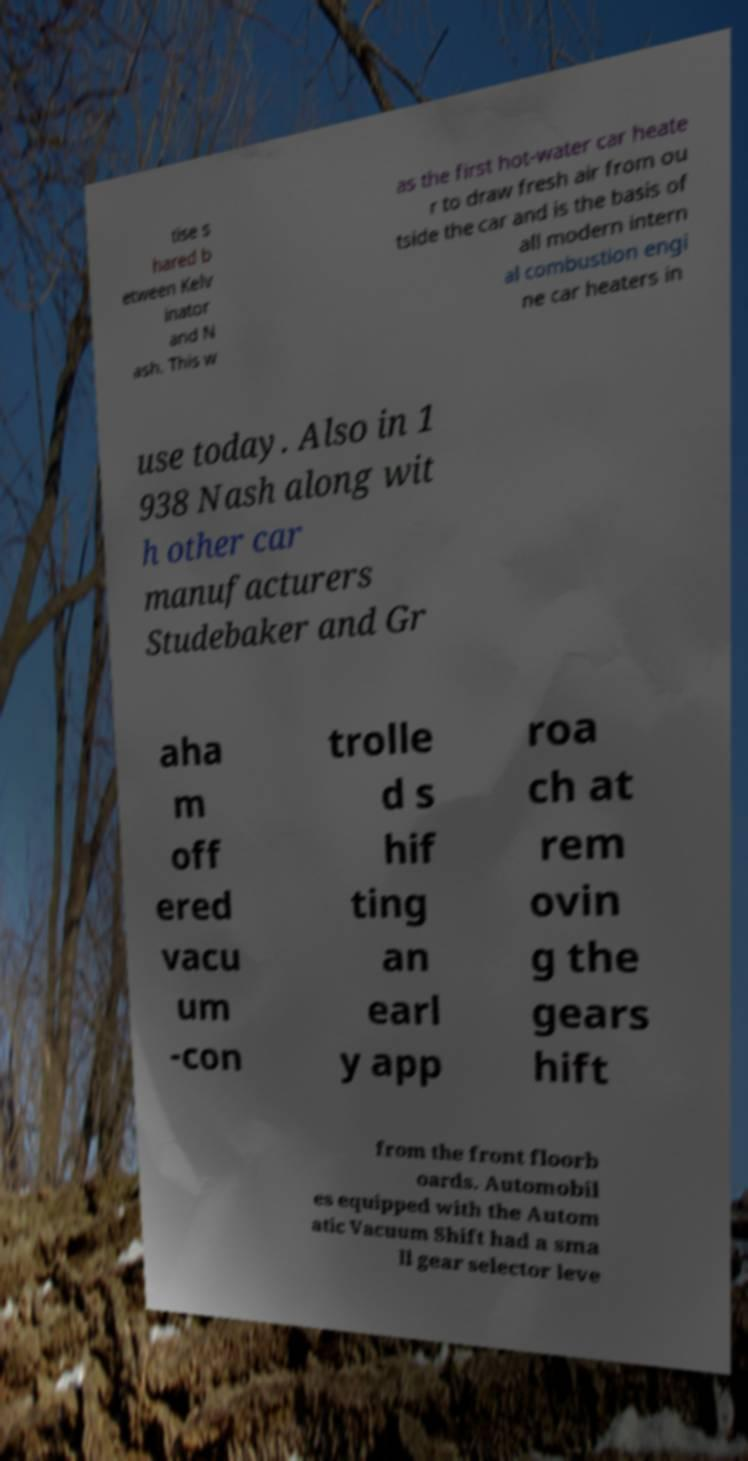Could you extract and type out the text from this image? tise s hared b etween Kelv inator and N ash. This w as the first hot-water car heate r to draw fresh air from ou tside the car and is the basis of all modern intern al combustion engi ne car heaters in use today. Also in 1 938 Nash along wit h other car manufacturers Studebaker and Gr aha m off ered vacu um -con trolle d s hif ting an earl y app roa ch at rem ovin g the gears hift from the front floorb oards. Automobil es equipped with the Autom atic Vacuum Shift had a sma ll gear selector leve 